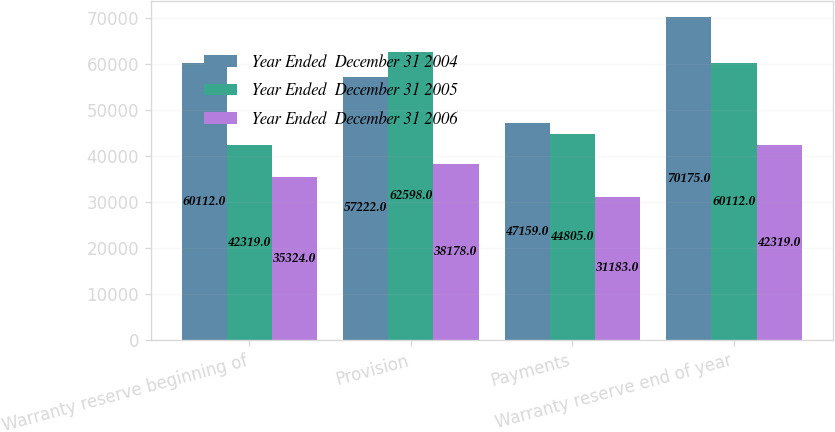<chart> <loc_0><loc_0><loc_500><loc_500><stacked_bar_chart><ecel><fcel>Warranty reserve beginning of<fcel>Provision<fcel>Payments<fcel>Warranty reserve end of year<nl><fcel>Year Ended  December 31 2004<fcel>60112<fcel>57222<fcel>47159<fcel>70175<nl><fcel>Year Ended  December 31 2005<fcel>42319<fcel>62598<fcel>44805<fcel>60112<nl><fcel>Year Ended  December 31 2006<fcel>35324<fcel>38178<fcel>31183<fcel>42319<nl></chart> 